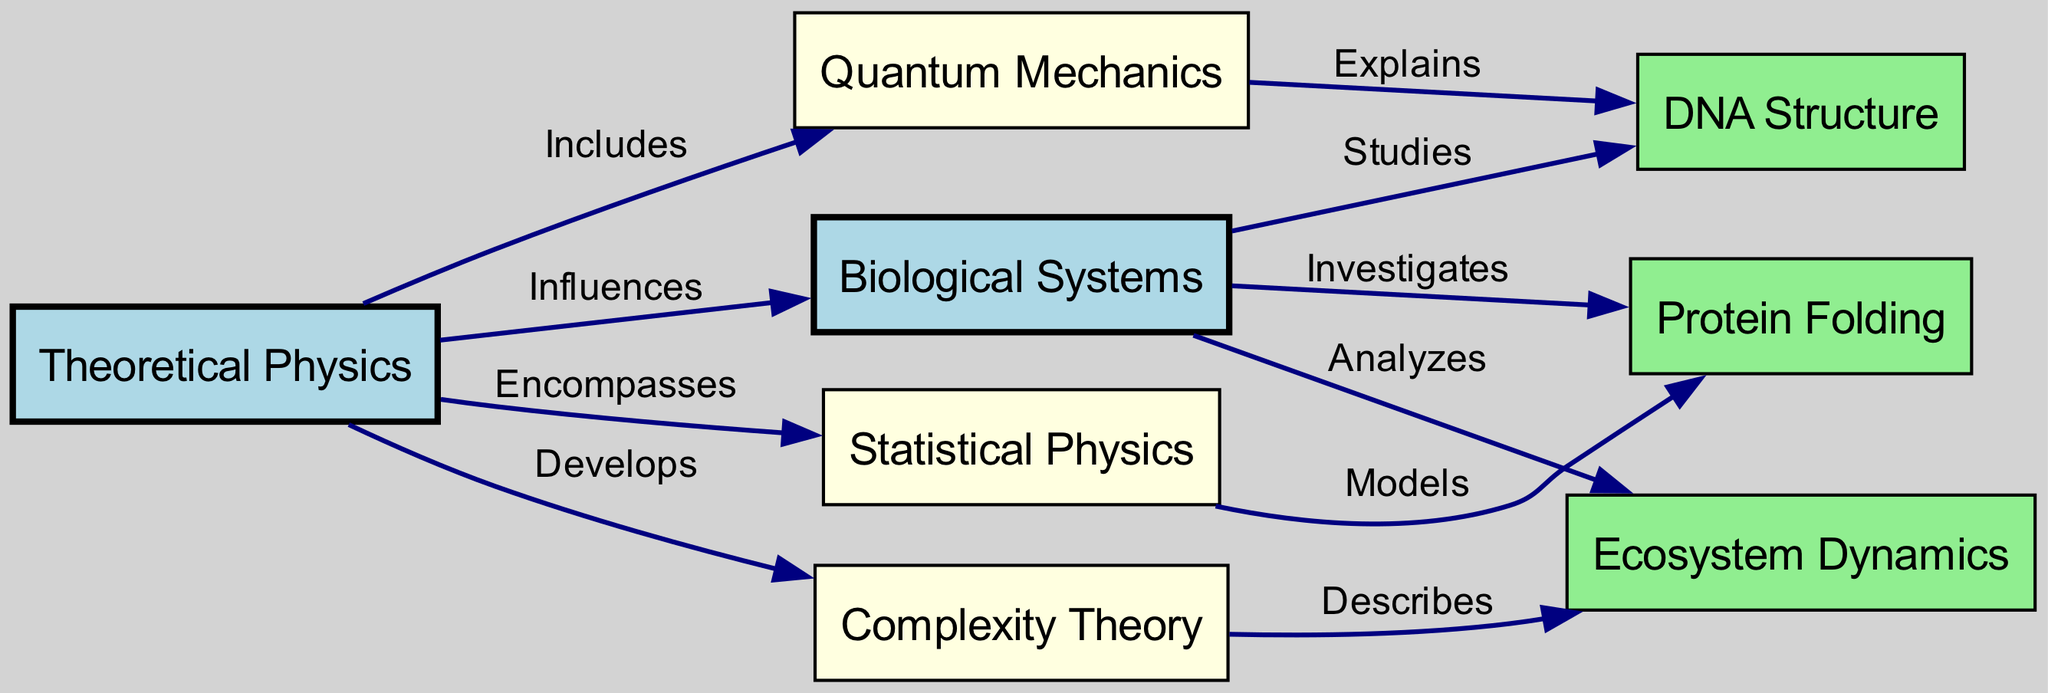What is the total number of nodes in the diagram? The nodes listed in the data are: Theoretical Physics, Biological Systems, Quantum Mechanics, DNA Structure, Statistical Physics, Protein Folding, Complexity Theory, and Ecosystem Dynamics. Counting them gives us a total of 8 nodes.
Answer: 8 Which node does "Statistical Physics" connect to and how? The edge from "Statistical Physics" shows that it connects to "Protein Folding" with the relationship labeled as "Models". Hence, the connection indicates that Statistical Physics models Protein Folding.
Answer: Protein Folding What type of relationship exists between "Theoretical Physics" and "Biological Systems"? The edge from "Theoretical Physics" to "Biological Systems" is labeled "Influences". This indicates that Theoretical Physics influences Biological Systems.
Answer: Influences Which node is described as "Investigates"? According to the edges, "Biological Systems" has an outgoing edge to "Protein Folding" labeled "Investigates". Therefore, the node that is described as "Investigates" is Protein Folding.
Answer: Protein Folding How many edges are there in total from "Biological Systems"? There are three edges originating from the "Biological Systems" node: to "DNA Structure" (Studies), "Protein Folding" (Investigates), and "Ecosystem Dynamics" (Analyzes). Counting these edges gives a total of 3.
Answer: 3 What relationships does "Complexity Theory" have with other nodes? Looking at the edges, "Complexity Theory" connects only to "Ecosystem Dynamics" with the relationship labeled "Describes". Thus, it only has this relationship with one other node.
Answer: Describes Which node is encompassed by "Theoretical Physics"? From the edges, we can see that "Theoretical Physics" encompasses "Statistical Physics". Thus, the specific node encompassed by Theoretical Physics is Statistical Physics.
Answer: Statistical Physics Which concepts constitute the influence of "Theoretical Physics"? "Theoretical Physics" influences "Biological Systems", and directly connects to "Quantum Mechanics", "Statistical Physics", and "Complexity Theory". This outlines the concepts it includes or influences.
Answer: Biological Systems, Quantum Mechanics, Statistical Physics, Complexity Theory 